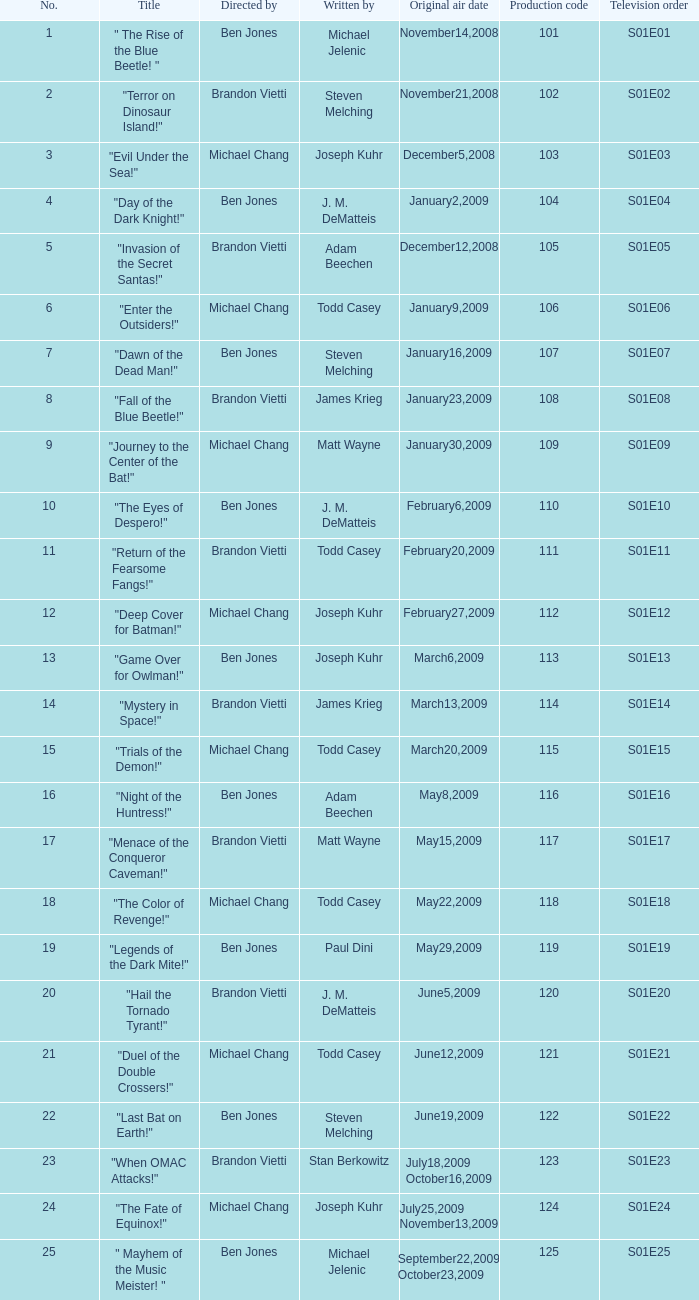Who directed s01e13 Ben Jones. 